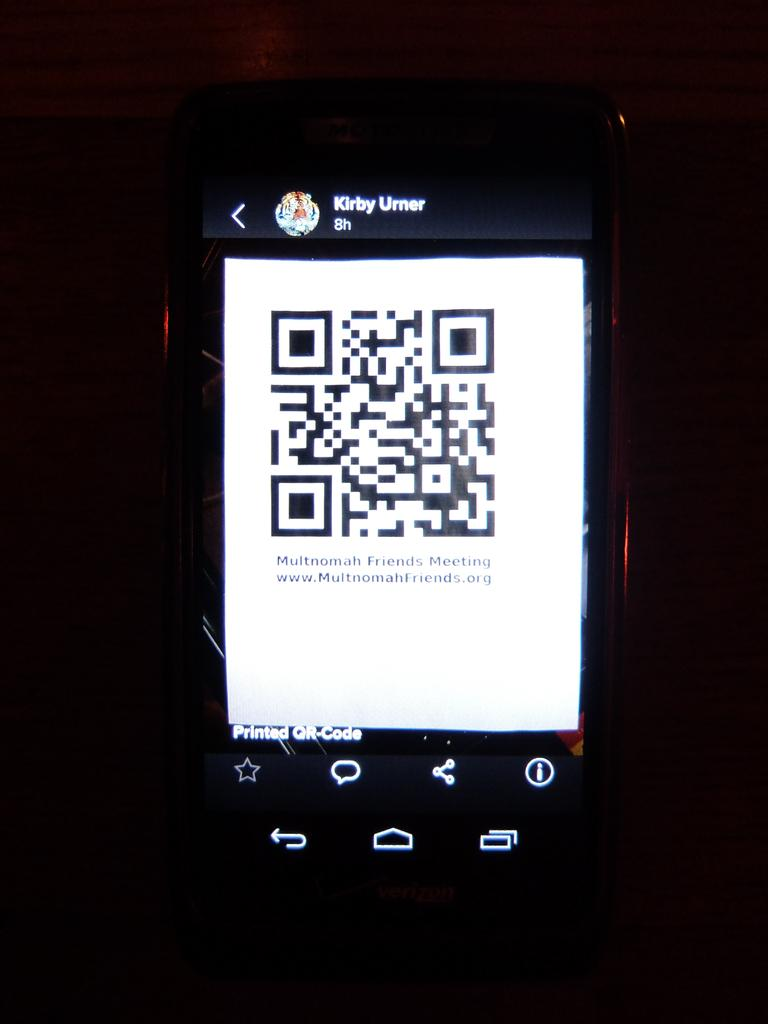<image>
Provide a brief description of the given image. A QR code for Multnomah Friends Meeting on a mobile phone. 